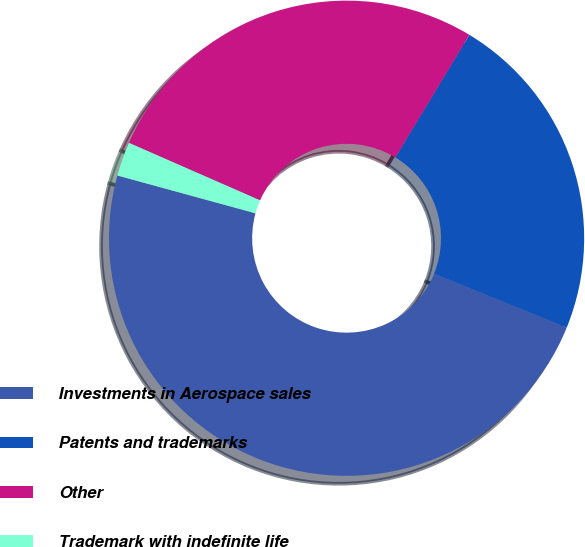Convert chart. <chart><loc_0><loc_0><loc_500><loc_500><pie_chart><fcel>Investments in Aerospace sales<fcel>Patents and trademarks<fcel>Other<fcel>Trademark with indefinite life<nl><fcel>48.11%<fcel>22.49%<fcel>27.07%<fcel>2.32%<nl></chart> 